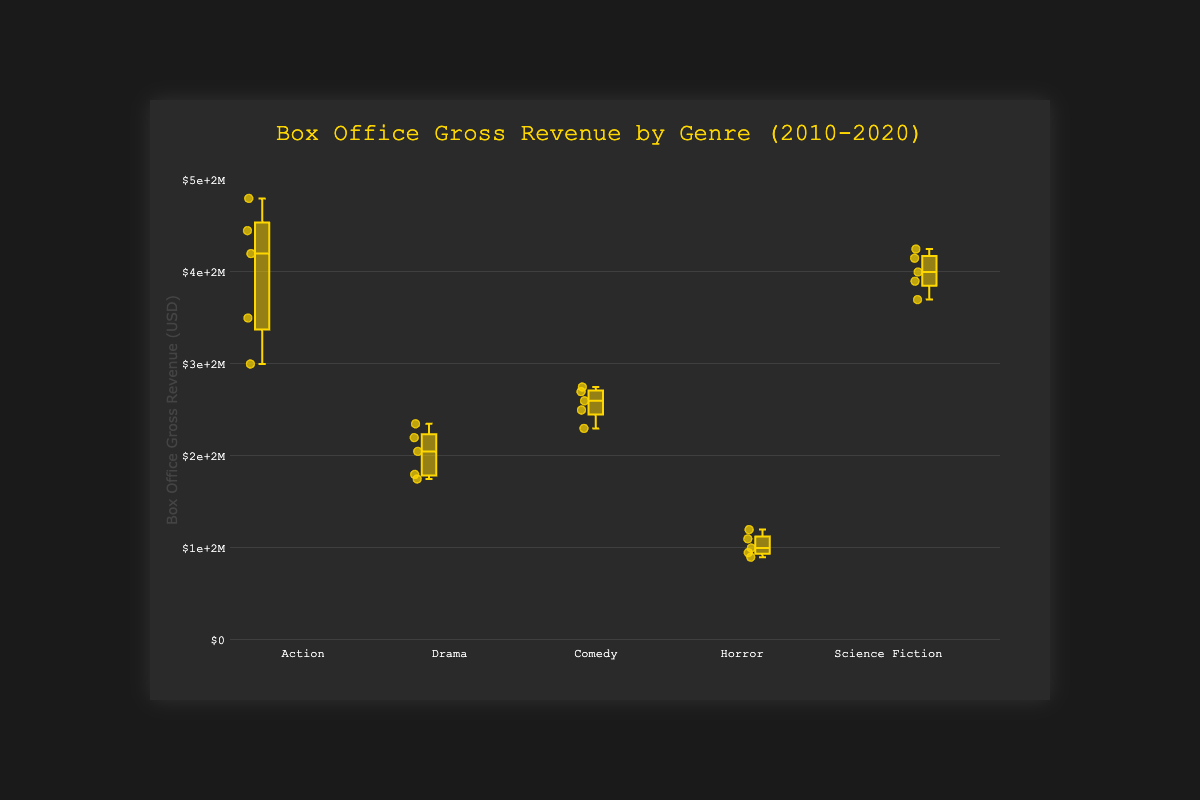What is the title of the box plot? The title is located at the top of the box plot and provides an overall idea of what the plot is about.
Answer: Box Office Gross Revenue by Genre (2010-2020) What is the range of the y-axis in the plot? The y-axis range can be found by looking at the minimum and maximum values displayed alongside the y-axis, which are marked in currency format.
Answer: 0 to 500,000,000 Which genre has the highest median box office gross revenue? To find this, look at the central line within each box for all genres and identify the highest value.
Answer: Science Fiction What is the median box office gross revenue for the Horror genre? The median is represented by the line inside the box; locate the central line of the Horror genre’s box.
Answer: 100,000,000 How does the distribution of Comedy movies' box office revenues compare to Action movies? Compare the spread and centering of the box and whiskers for both genres to understand the differences in the data distributions.
Answer: Comedy has a narrower distribution and lower revenues compared to Action Which genre has the smallest interquartile range (IQR) for box office gross revenue? The IQR can be judged by the length of the box; the genre with the shortest box has the smallest IQR.
Answer: Horror What is the maximum box office gross revenue recorded for Science Fiction movies? The maximum value can be identified as the top 'whisker' or outlier point in the Science Fiction box.
Answer: 425,000,000 How many genres have a median box office gross revenue above 200 million dollars? Count the number of genres where the median (middle line of the box) is situated above the 200 million mark on the y-axis.
Answer: Three In which genre is the spread (range) of box office gross revenue the largest? The spread is determined by the distance between the minimum and maximum whiskers or the range of outlier points.
Answer: Action Between Drama and Comedy, which genre has a higher first quartile box office gross revenue? The first quartile (Q1) is the bottom edge of each box; compare the bottom edges of Drama and Comedy boxes.
Answer: Comedy 